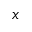<formula> <loc_0><loc_0><loc_500><loc_500>x</formula> 